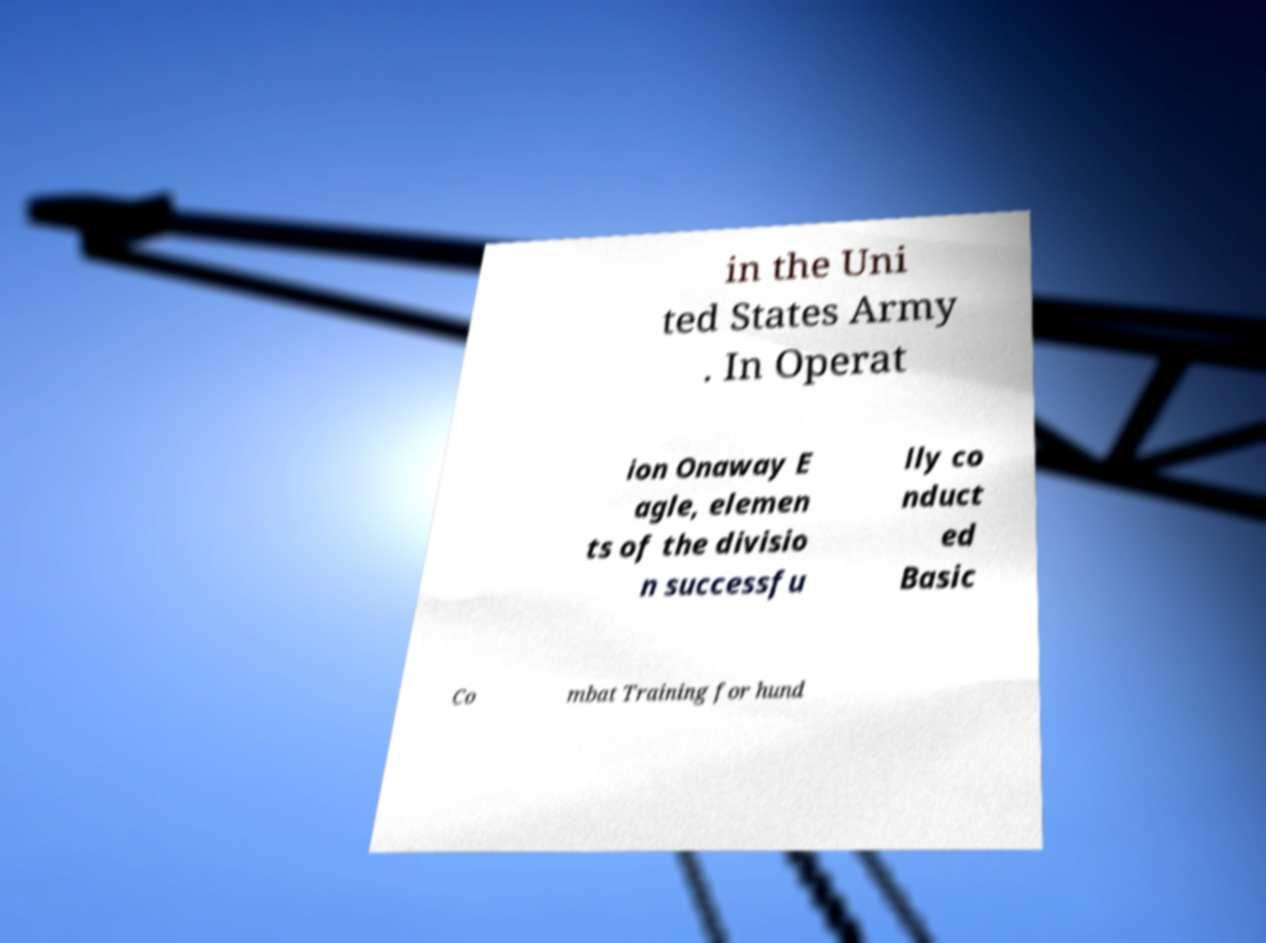For documentation purposes, I need the text within this image transcribed. Could you provide that? in the Uni ted States Army . In Operat ion Onaway E agle, elemen ts of the divisio n successfu lly co nduct ed Basic Co mbat Training for hund 